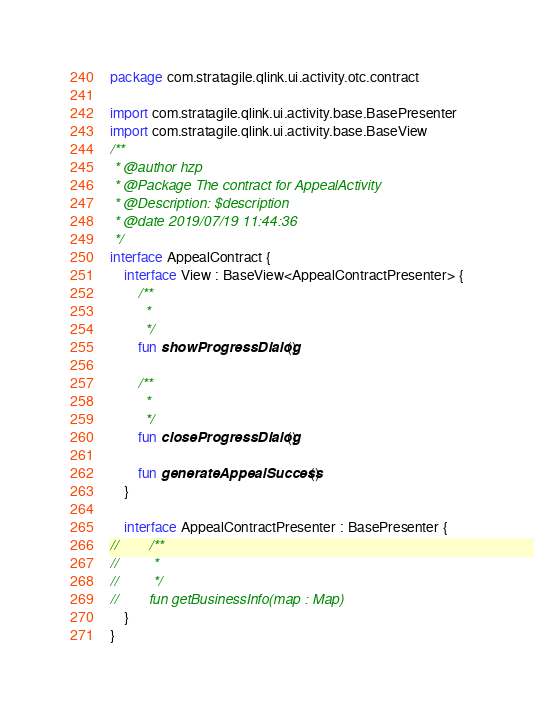Convert code to text. <code><loc_0><loc_0><loc_500><loc_500><_Kotlin_>package com.stratagile.qlink.ui.activity.otc.contract

import com.stratagile.qlink.ui.activity.base.BasePresenter
import com.stratagile.qlink.ui.activity.base.BaseView
/**
 * @author hzp
 * @Package The contract for AppealActivity
 * @Description: $description
 * @date 2019/07/19 11:44:36
 */
interface AppealContract {
    interface View : BaseView<AppealContractPresenter> {
        /**
         *
         */
        fun showProgressDialog()

        /**
         *
         */
        fun closeProgressDialog()

        fun generateAppealSuccess()
    }

    interface AppealContractPresenter : BasePresenter {
//        /**
//         *
//         */
//        fun getBusinessInfo(map : Map)
    }
}</code> 